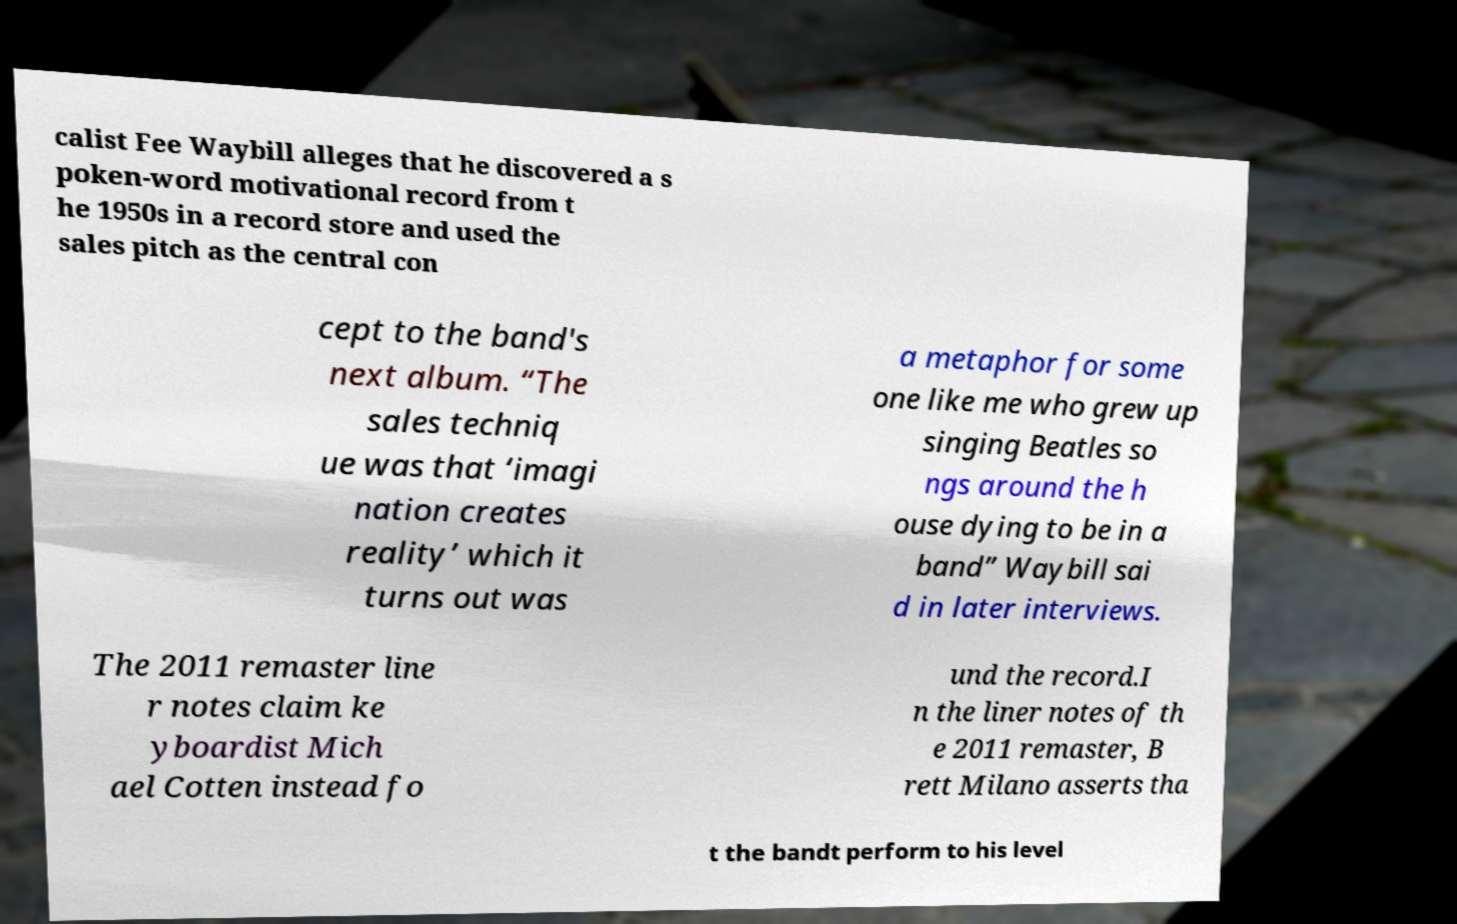Can you read and provide the text displayed in the image?This photo seems to have some interesting text. Can you extract and type it out for me? calist Fee Waybill alleges that he discovered a s poken-word motivational record from t he 1950s in a record store and used the sales pitch as the central con cept to the band's next album. “The sales techniq ue was that ‘imagi nation creates reality’ which it turns out was a metaphor for some one like me who grew up singing Beatles so ngs around the h ouse dying to be in a band” Waybill sai d in later interviews. The 2011 remaster line r notes claim ke yboardist Mich ael Cotten instead fo und the record.I n the liner notes of th e 2011 remaster, B rett Milano asserts tha t the bandt perform to his level 